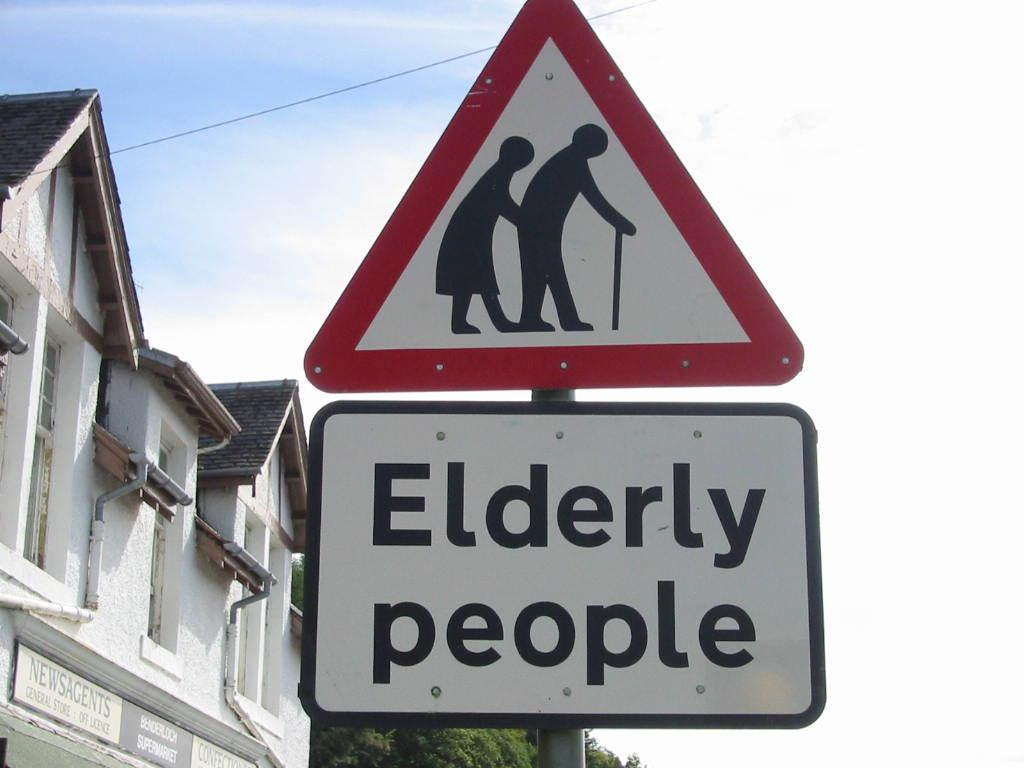<image>
Offer a succinct explanation of the picture presented. an elderly people crossing sign that is on the street 